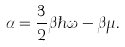<formula> <loc_0><loc_0><loc_500><loc_500>\alpha = \frac { 3 } { 2 } \beta \hbar { \omega } - \beta \mu .</formula> 